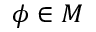Convert formula to latex. <formula><loc_0><loc_0><loc_500><loc_500>\phi \in M</formula> 